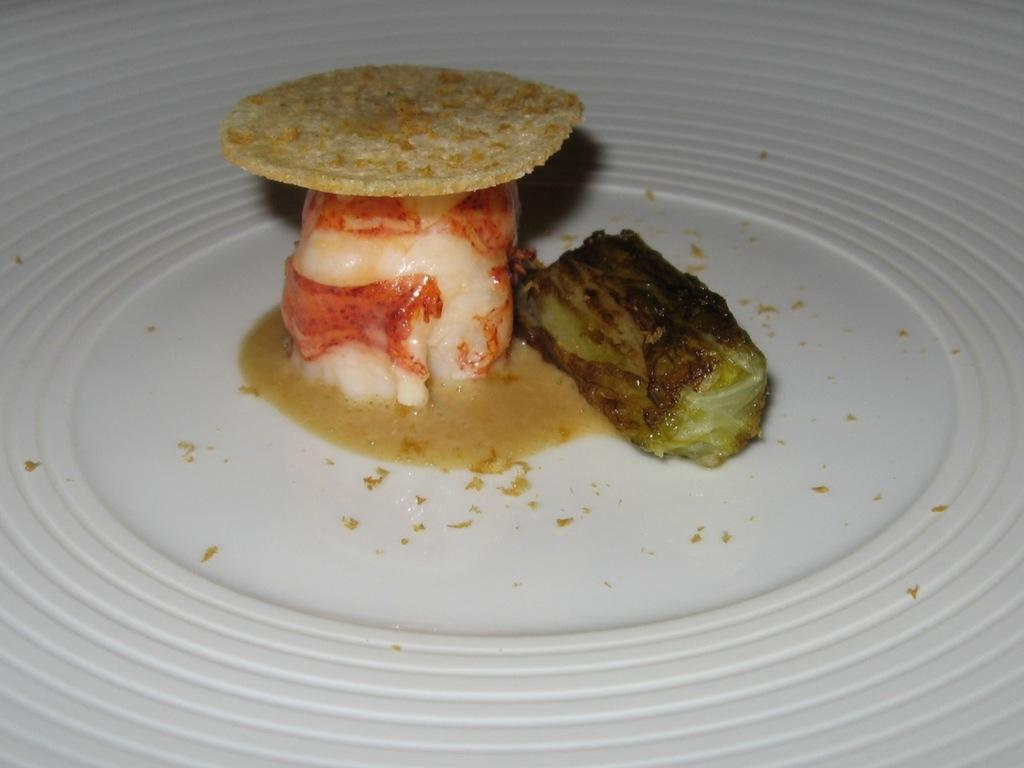What is the main subject of the image? There is a white object in the image. What is on the white object? The white object has different types of food on it. Can you describe the colors of the food? The colors of the food include white, black, red, and cream. What date is circled on the calendar in the image? There is no calendar present in the image. What arithmetic problem is being solved on the white object? There is no arithmetic problem present on the white object; it is covered with food. What type of airport is depicted in the image? There is no airport present in the image. 